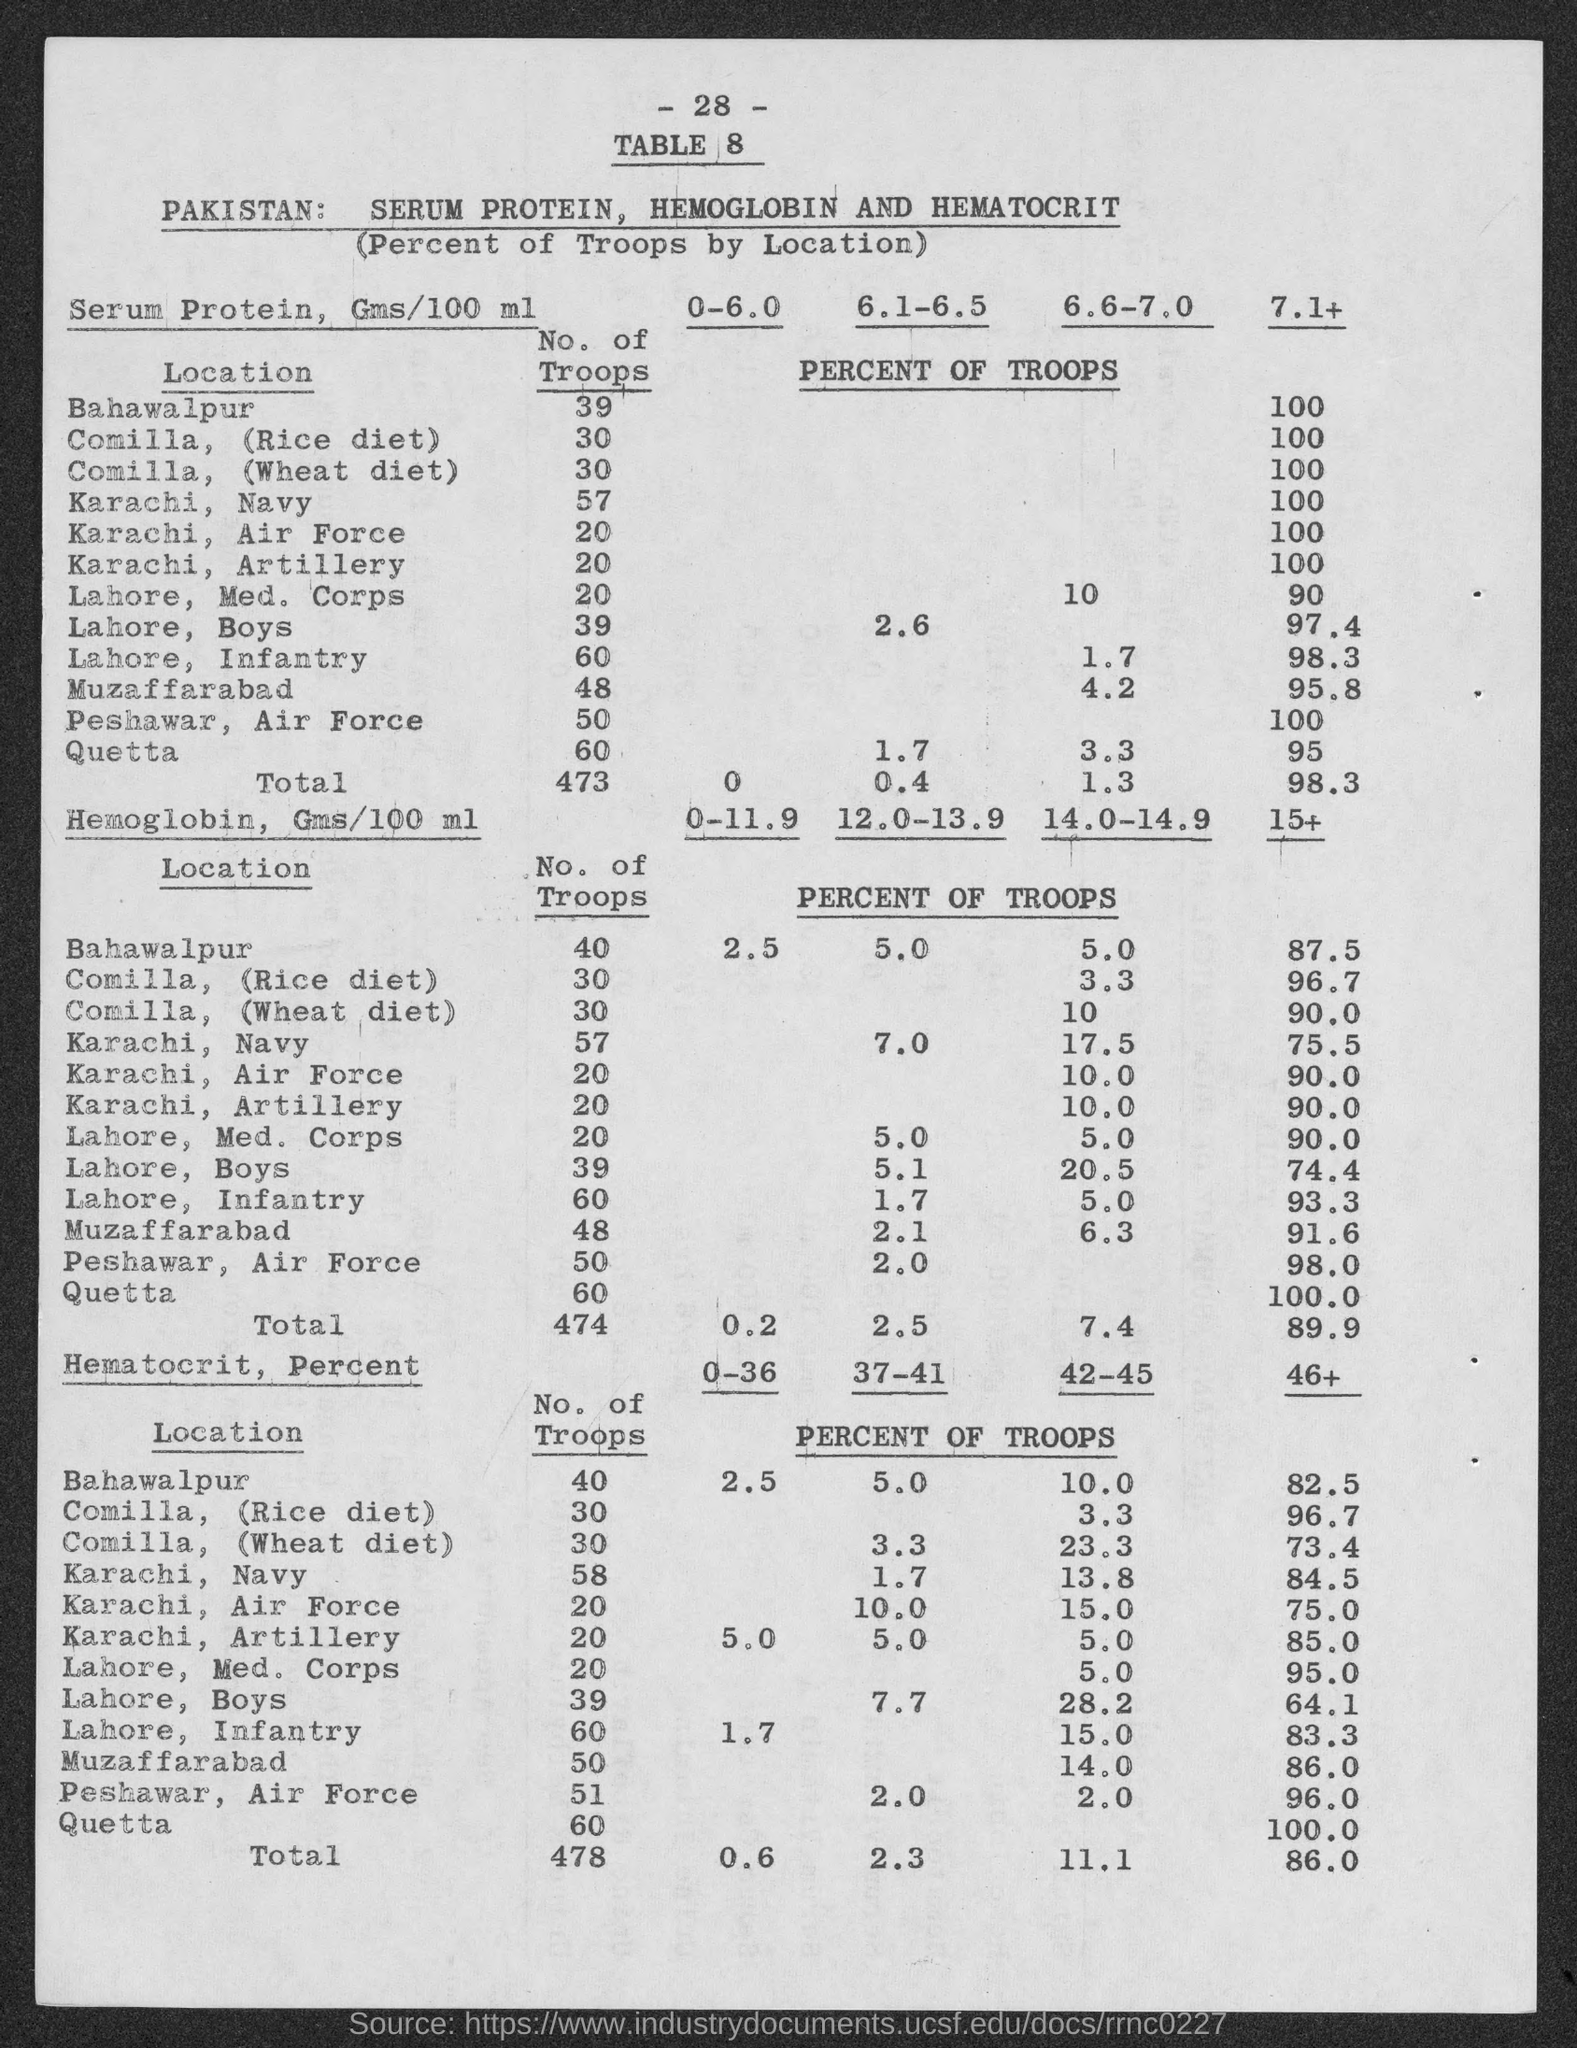What is the page no. of table?
Provide a short and direct response. 28. What is the total no. of troops for serum protien?
Give a very brief answer. 473. 